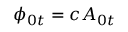Convert formula to latex. <formula><loc_0><loc_0><loc_500><loc_500>\phi _ { 0 t } = c A _ { 0 t }</formula> 